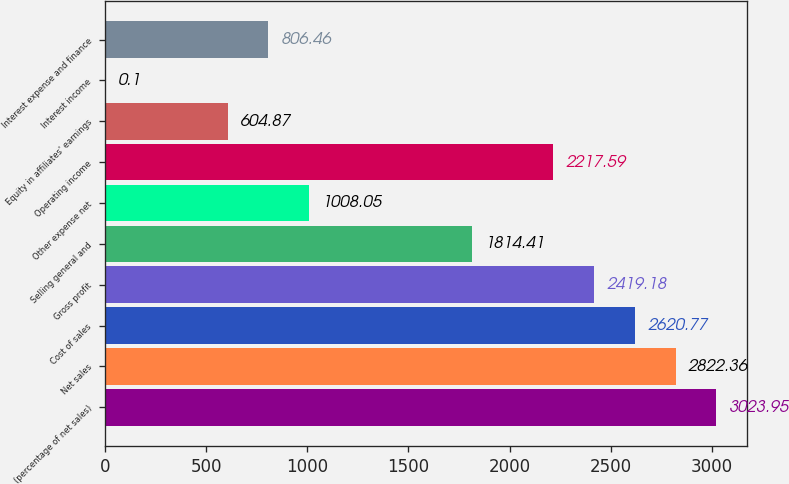<chart> <loc_0><loc_0><loc_500><loc_500><bar_chart><fcel>(percentage of net sales)<fcel>Net sales<fcel>Cost of sales<fcel>Gross profit<fcel>Selling general and<fcel>Other expense net<fcel>Operating income<fcel>Equity in affiliates' earnings<fcel>Interest income<fcel>Interest expense and finance<nl><fcel>3023.95<fcel>2822.36<fcel>2620.77<fcel>2419.18<fcel>1814.41<fcel>1008.05<fcel>2217.59<fcel>604.87<fcel>0.1<fcel>806.46<nl></chart> 